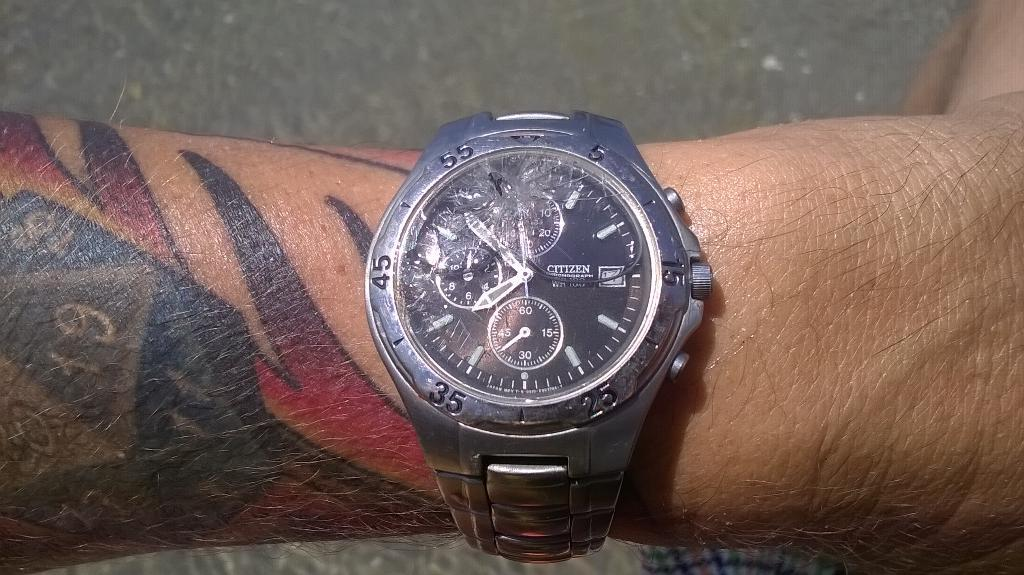Provide a one-sentence caption for the provided image. a watch on a tattoed mans wtrist the time is 8:45. 